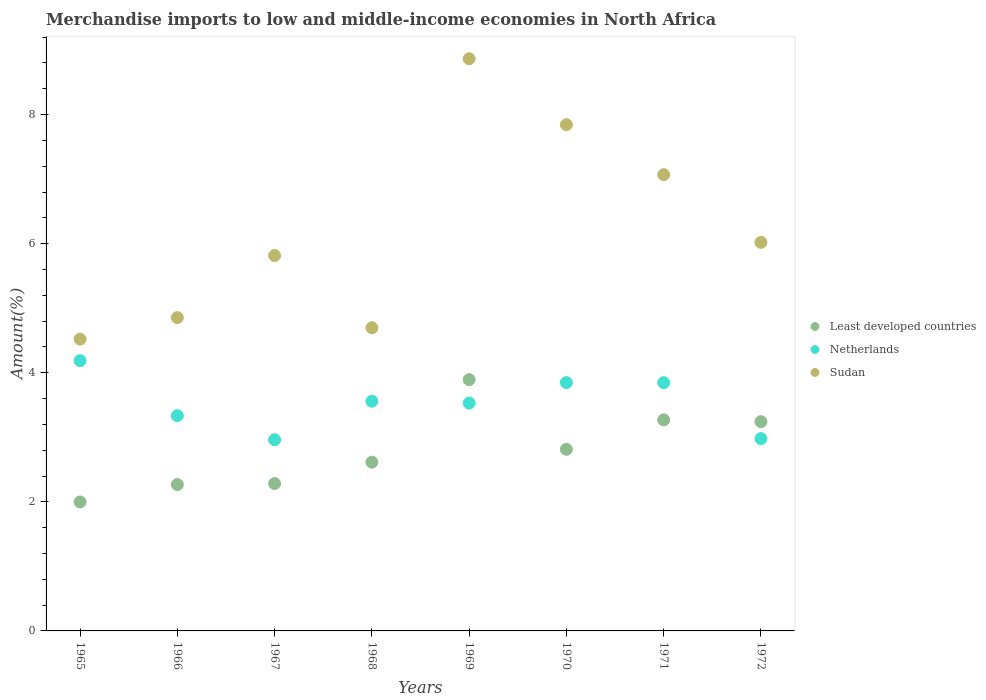How many different coloured dotlines are there?
Keep it short and to the point. 3. What is the percentage of amount earned from merchandise imports in Sudan in 1968?
Your response must be concise. 4.7. Across all years, what is the maximum percentage of amount earned from merchandise imports in Least developed countries?
Ensure brevity in your answer.  3.89. Across all years, what is the minimum percentage of amount earned from merchandise imports in Least developed countries?
Keep it short and to the point. 2. In which year was the percentage of amount earned from merchandise imports in Least developed countries maximum?
Make the answer very short. 1969. In which year was the percentage of amount earned from merchandise imports in Least developed countries minimum?
Make the answer very short. 1965. What is the total percentage of amount earned from merchandise imports in Sudan in the graph?
Make the answer very short. 49.69. What is the difference between the percentage of amount earned from merchandise imports in Netherlands in 1969 and that in 1970?
Your answer should be very brief. -0.32. What is the difference between the percentage of amount earned from merchandise imports in Sudan in 1966 and the percentage of amount earned from merchandise imports in Least developed countries in 1972?
Make the answer very short. 1.61. What is the average percentage of amount earned from merchandise imports in Netherlands per year?
Your answer should be compact. 3.53. In the year 1969, what is the difference between the percentage of amount earned from merchandise imports in Least developed countries and percentage of amount earned from merchandise imports in Netherlands?
Keep it short and to the point. 0.36. What is the ratio of the percentage of amount earned from merchandise imports in Least developed countries in 1967 to that in 1971?
Provide a succinct answer. 0.7. Is the percentage of amount earned from merchandise imports in Netherlands in 1968 less than that in 1971?
Keep it short and to the point. Yes. What is the difference between the highest and the second highest percentage of amount earned from merchandise imports in Least developed countries?
Provide a short and direct response. 0.62. What is the difference between the highest and the lowest percentage of amount earned from merchandise imports in Sudan?
Provide a short and direct response. 4.34. Is the sum of the percentage of amount earned from merchandise imports in Least developed countries in 1966 and 1972 greater than the maximum percentage of amount earned from merchandise imports in Netherlands across all years?
Provide a succinct answer. Yes. Is it the case that in every year, the sum of the percentage of amount earned from merchandise imports in Least developed countries and percentage of amount earned from merchandise imports in Netherlands  is greater than the percentage of amount earned from merchandise imports in Sudan?
Ensure brevity in your answer.  No. Does the percentage of amount earned from merchandise imports in Least developed countries monotonically increase over the years?
Keep it short and to the point. No. Is the percentage of amount earned from merchandise imports in Least developed countries strictly less than the percentage of amount earned from merchandise imports in Netherlands over the years?
Offer a terse response. No. How many dotlines are there?
Keep it short and to the point. 3. Are the values on the major ticks of Y-axis written in scientific E-notation?
Make the answer very short. No. Does the graph contain any zero values?
Offer a terse response. No. Does the graph contain grids?
Ensure brevity in your answer.  No. Where does the legend appear in the graph?
Provide a short and direct response. Center right. How many legend labels are there?
Provide a short and direct response. 3. What is the title of the graph?
Your answer should be compact. Merchandise imports to low and middle-income economies in North Africa. Does "United Kingdom" appear as one of the legend labels in the graph?
Your response must be concise. No. What is the label or title of the X-axis?
Offer a terse response. Years. What is the label or title of the Y-axis?
Provide a succinct answer. Amount(%). What is the Amount(%) in Least developed countries in 1965?
Keep it short and to the point. 2. What is the Amount(%) in Netherlands in 1965?
Keep it short and to the point. 4.19. What is the Amount(%) in Sudan in 1965?
Offer a terse response. 4.52. What is the Amount(%) in Least developed countries in 1966?
Your response must be concise. 2.27. What is the Amount(%) in Netherlands in 1966?
Give a very brief answer. 3.33. What is the Amount(%) in Sudan in 1966?
Your answer should be very brief. 4.85. What is the Amount(%) in Least developed countries in 1967?
Make the answer very short. 2.28. What is the Amount(%) in Netherlands in 1967?
Provide a short and direct response. 2.96. What is the Amount(%) in Sudan in 1967?
Make the answer very short. 5.82. What is the Amount(%) of Least developed countries in 1968?
Provide a short and direct response. 2.61. What is the Amount(%) in Netherlands in 1968?
Offer a terse response. 3.56. What is the Amount(%) in Sudan in 1968?
Keep it short and to the point. 4.7. What is the Amount(%) of Least developed countries in 1969?
Keep it short and to the point. 3.89. What is the Amount(%) of Netherlands in 1969?
Your answer should be compact. 3.53. What is the Amount(%) in Sudan in 1969?
Give a very brief answer. 8.87. What is the Amount(%) of Least developed countries in 1970?
Your response must be concise. 2.81. What is the Amount(%) of Netherlands in 1970?
Give a very brief answer. 3.85. What is the Amount(%) of Sudan in 1970?
Your answer should be very brief. 7.84. What is the Amount(%) of Least developed countries in 1971?
Provide a short and direct response. 3.27. What is the Amount(%) of Netherlands in 1971?
Your answer should be compact. 3.85. What is the Amount(%) of Sudan in 1971?
Provide a short and direct response. 7.07. What is the Amount(%) of Least developed countries in 1972?
Give a very brief answer. 3.24. What is the Amount(%) in Netherlands in 1972?
Offer a very short reply. 2.98. What is the Amount(%) in Sudan in 1972?
Make the answer very short. 6.02. Across all years, what is the maximum Amount(%) of Least developed countries?
Offer a very short reply. 3.89. Across all years, what is the maximum Amount(%) in Netherlands?
Your response must be concise. 4.19. Across all years, what is the maximum Amount(%) of Sudan?
Provide a succinct answer. 8.87. Across all years, what is the minimum Amount(%) in Least developed countries?
Provide a succinct answer. 2. Across all years, what is the minimum Amount(%) of Netherlands?
Ensure brevity in your answer.  2.96. Across all years, what is the minimum Amount(%) in Sudan?
Offer a very short reply. 4.52. What is the total Amount(%) in Least developed countries in the graph?
Your answer should be compact. 22.38. What is the total Amount(%) in Netherlands in the graph?
Offer a very short reply. 28.25. What is the total Amount(%) of Sudan in the graph?
Offer a terse response. 49.69. What is the difference between the Amount(%) in Least developed countries in 1965 and that in 1966?
Offer a very short reply. -0.27. What is the difference between the Amount(%) in Netherlands in 1965 and that in 1966?
Offer a very short reply. 0.85. What is the difference between the Amount(%) in Sudan in 1965 and that in 1966?
Make the answer very short. -0.33. What is the difference between the Amount(%) of Least developed countries in 1965 and that in 1967?
Offer a very short reply. -0.29. What is the difference between the Amount(%) in Netherlands in 1965 and that in 1967?
Keep it short and to the point. 1.23. What is the difference between the Amount(%) of Sudan in 1965 and that in 1967?
Ensure brevity in your answer.  -1.29. What is the difference between the Amount(%) in Least developed countries in 1965 and that in 1968?
Provide a short and direct response. -0.62. What is the difference between the Amount(%) in Netherlands in 1965 and that in 1968?
Ensure brevity in your answer.  0.63. What is the difference between the Amount(%) in Sudan in 1965 and that in 1968?
Offer a terse response. -0.18. What is the difference between the Amount(%) in Least developed countries in 1965 and that in 1969?
Provide a short and direct response. -1.89. What is the difference between the Amount(%) of Netherlands in 1965 and that in 1969?
Your answer should be compact. 0.66. What is the difference between the Amount(%) in Sudan in 1965 and that in 1969?
Your answer should be very brief. -4.34. What is the difference between the Amount(%) in Least developed countries in 1965 and that in 1970?
Provide a short and direct response. -0.82. What is the difference between the Amount(%) of Netherlands in 1965 and that in 1970?
Offer a very short reply. 0.34. What is the difference between the Amount(%) of Sudan in 1965 and that in 1970?
Your answer should be compact. -3.32. What is the difference between the Amount(%) of Least developed countries in 1965 and that in 1971?
Offer a very short reply. -1.27. What is the difference between the Amount(%) of Netherlands in 1965 and that in 1971?
Offer a terse response. 0.34. What is the difference between the Amount(%) in Sudan in 1965 and that in 1971?
Offer a very short reply. -2.55. What is the difference between the Amount(%) of Least developed countries in 1965 and that in 1972?
Your answer should be compact. -1.24. What is the difference between the Amount(%) in Netherlands in 1965 and that in 1972?
Provide a short and direct response. 1.21. What is the difference between the Amount(%) of Sudan in 1965 and that in 1972?
Provide a short and direct response. -1.5. What is the difference between the Amount(%) in Least developed countries in 1966 and that in 1967?
Your answer should be compact. -0.02. What is the difference between the Amount(%) in Netherlands in 1966 and that in 1967?
Give a very brief answer. 0.37. What is the difference between the Amount(%) of Sudan in 1966 and that in 1967?
Offer a very short reply. -0.96. What is the difference between the Amount(%) in Least developed countries in 1966 and that in 1968?
Give a very brief answer. -0.35. What is the difference between the Amount(%) of Netherlands in 1966 and that in 1968?
Give a very brief answer. -0.22. What is the difference between the Amount(%) of Sudan in 1966 and that in 1968?
Your response must be concise. 0.16. What is the difference between the Amount(%) in Least developed countries in 1966 and that in 1969?
Ensure brevity in your answer.  -1.62. What is the difference between the Amount(%) in Netherlands in 1966 and that in 1969?
Offer a terse response. -0.2. What is the difference between the Amount(%) in Sudan in 1966 and that in 1969?
Provide a short and direct response. -4.01. What is the difference between the Amount(%) of Least developed countries in 1966 and that in 1970?
Make the answer very short. -0.55. What is the difference between the Amount(%) of Netherlands in 1966 and that in 1970?
Your response must be concise. -0.51. What is the difference between the Amount(%) in Sudan in 1966 and that in 1970?
Make the answer very short. -2.99. What is the difference between the Amount(%) in Least developed countries in 1966 and that in 1971?
Give a very brief answer. -1. What is the difference between the Amount(%) of Netherlands in 1966 and that in 1971?
Provide a short and direct response. -0.51. What is the difference between the Amount(%) in Sudan in 1966 and that in 1971?
Ensure brevity in your answer.  -2.22. What is the difference between the Amount(%) of Least developed countries in 1966 and that in 1972?
Provide a succinct answer. -0.97. What is the difference between the Amount(%) of Netherlands in 1966 and that in 1972?
Provide a succinct answer. 0.36. What is the difference between the Amount(%) in Sudan in 1966 and that in 1972?
Provide a succinct answer. -1.17. What is the difference between the Amount(%) in Least developed countries in 1967 and that in 1968?
Ensure brevity in your answer.  -0.33. What is the difference between the Amount(%) of Netherlands in 1967 and that in 1968?
Your answer should be very brief. -0.6. What is the difference between the Amount(%) of Sudan in 1967 and that in 1968?
Give a very brief answer. 1.12. What is the difference between the Amount(%) of Least developed countries in 1967 and that in 1969?
Your response must be concise. -1.61. What is the difference between the Amount(%) of Netherlands in 1967 and that in 1969?
Offer a terse response. -0.57. What is the difference between the Amount(%) in Sudan in 1967 and that in 1969?
Make the answer very short. -3.05. What is the difference between the Amount(%) in Least developed countries in 1967 and that in 1970?
Offer a very short reply. -0.53. What is the difference between the Amount(%) of Netherlands in 1967 and that in 1970?
Your answer should be compact. -0.89. What is the difference between the Amount(%) in Sudan in 1967 and that in 1970?
Make the answer very short. -2.03. What is the difference between the Amount(%) in Least developed countries in 1967 and that in 1971?
Give a very brief answer. -0.99. What is the difference between the Amount(%) in Netherlands in 1967 and that in 1971?
Your answer should be very brief. -0.88. What is the difference between the Amount(%) of Sudan in 1967 and that in 1971?
Your response must be concise. -1.25. What is the difference between the Amount(%) of Least developed countries in 1967 and that in 1972?
Provide a succinct answer. -0.96. What is the difference between the Amount(%) of Netherlands in 1967 and that in 1972?
Keep it short and to the point. -0.02. What is the difference between the Amount(%) of Sudan in 1967 and that in 1972?
Give a very brief answer. -0.2. What is the difference between the Amount(%) of Least developed countries in 1968 and that in 1969?
Offer a terse response. -1.28. What is the difference between the Amount(%) of Netherlands in 1968 and that in 1969?
Your answer should be compact. 0.03. What is the difference between the Amount(%) in Sudan in 1968 and that in 1969?
Give a very brief answer. -4.17. What is the difference between the Amount(%) in Least developed countries in 1968 and that in 1970?
Provide a succinct answer. -0.2. What is the difference between the Amount(%) of Netherlands in 1968 and that in 1970?
Your answer should be compact. -0.29. What is the difference between the Amount(%) in Sudan in 1968 and that in 1970?
Offer a very short reply. -3.15. What is the difference between the Amount(%) of Least developed countries in 1968 and that in 1971?
Provide a short and direct response. -0.65. What is the difference between the Amount(%) of Netherlands in 1968 and that in 1971?
Your answer should be very brief. -0.29. What is the difference between the Amount(%) in Sudan in 1968 and that in 1971?
Your answer should be very brief. -2.37. What is the difference between the Amount(%) of Least developed countries in 1968 and that in 1972?
Your answer should be very brief. -0.63. What is the difference between the Amount(%) in Netherlands in 1968 and that in 1972?
Keep it short and to the point. 0.58. What is the difference between the Amount(%) in Sudan in 1968 and that in 1972?
Your answer should be compact. -1.32. What is the difference between the Amount(%) in Least developed countries in 1969 and that in 1970?
Your response must be concise. 1.08. What is the difference between the Amount(%) in Netherlands in 1969 and that in 1970?
Your answer should be very brief. -0.32. What is the difference between the Amount(%) in Sudan in 1969 and that in 1970?
Provide a short and direct response. 1.02. What is the difference between the Amount(%) of Least developed countries in 1969 and that in 1971?
Provide a succinct answer. 0.62. What is the difference between the Amount(%) of Netherlands in 1969 and that in 1971?
Give a very brief answer. -0.32. What is the difference between the Amount(%) in Sudan in 1969 and that in 1971?
Your answer should be very brief. 1.8. What is the difference between the Amount(%) of Least developed countries in 1969 and that in 1972?
Keep it short and to the point. 0.65. What is the difference between the Amount(%) of Netherlands in 1969 and that in 1972?
Give a very brief answer. 0.55. What is the difference between the Amount(%) in Sudan in 1969 and that in 1972?
Make the answer very short. 2.84. What is the difference between the Amount(%) of Least developed countries in 1970 and that in 1971?
Make the answer very short. -0.46. What is the difference between the Amount(%) of Netherlands in 1970 and that in 1971?
Your answer should be very brief. 0. What is the difference between the Amount(%) in Sudan in 1970 and that in 1971?
Give a very brief answer. 0.77. What is the difference between the Amount(%) of Least developed countries in 1970 and that in 1972?
Provide a short and direct response. -0.43. What is the difference between the Amount(%) of Netherlands in 1970 and that in 1972?
Offer a very short reply. 0.87. What is the difference between the Amount(%) of Sudan in 1970 and that in 1972?
Ensure brevity in your answer.  1.82. What is the difference between the Amount(%) of Least developed countries in 1971 and that in 1972?
Offer a very short reply. 0.03. What is the difference between the Amount(%) in Netherlands in 1971 and that in 1972?
Offer a very short reply. 0.87. What is the difference between the Amount(%) of Sudan in 1971 and that in 1972?
Your answer should be compact. 1.05. What is the difference between the Amount(%) of Least developed countries in 1965 and the Amount(%) of Netherlands in 1966?
Keep it short and to the point. -1.34. What is the difference between the Amount(%) in Least developed countries in 1965 and the Amount(%) in Sudan in 1966?
Make the answer very short. -2.86. What is the difference between the Amount(%) in Netherlands in 1965 and the Amount(%) in Sudan in 1966?
Your answer should be compact. -0.67. What is the difference between the Amount(%) in Least developed countries in 1965 and the Amount(%) in Netherlands in 1967?
Offer a terse response. -0.96. What is the difference between the Amount(%) of Least developed countries in 1965 and the Amount(%) of Sudan in 1967?
Your answer should be very brief. -3.82. What is the difference between the Amount(%) in Netherlands in 1965 and the Amount(%) in Sudan in 1967?
Your answer should be compact. -1.63. What is the difference between the Amount(%) in Least developed countries in 1965 and the Amount(%) in Netherlands in 1968?
Offer a terse response. -1.56. What is the difference between the Amount(%) of Least developed countries in 1965 and the Amount(%) of Sudan in 1968?
Offer a terse response. -2.7. What is the difference between the Amount(%) of Netherlands in 1965 and the Amount(%) of Sudan in 1968?
Provide a short and direct response. -0.51. What is the difference between the Amount(%) of Least developed countries in 1965 and the Amount(%) of Netherlands in 1969?
Offer a very short reply. -1.53. What is the difference between the Amount(%) in Least developed countries in 1965 and the Amount(%) in Sudan in 1969?
Your answer should be very brief. -6.87. What is the difference between the Amount(%) in Netherlands in 1965 and the Amount(%) in Sudan in 1969?
Keep it short and to the point. -4.68. What is the difference between the Amount(%) of Least developed countries in 1965 and the Amount(%) of Netherlands in 1970?
Your answer should be compact. -1.85. What is the difference between the Amount(%) in Least developed countries in 1965 and the Amount(%) in Sudan in 1970?
Make the answer very short. -5.85. What is the difference between the Amount(%) in Netherlands in 1965 and the Amount(%) in Sudan in 1970?
Your answer should be very brief. -3.66. What is the difference between the Amount(%) in Least developed countries in 1965 and the Amount(%) in Netherlands in 1971?
Your response must be concise. -1.85. What is the difference between the Amount(%) in Least developed countries in 1965 and the Amount(%) in Sudan in 1971?
Ensure brevity in your answer.  -5.07. What is the difference between the Amount(%) in Netherlands in 1965 and the Amount(%) in Sudan in 1971?
Keep it short and to the point. -2.88. What is the difference between the Amount(%) in Least developed countries in 1965 and the Amount(%) in Netherlands in 1972?
Keep it short and to the point. -0.98. What is the difference between the Amount(%) of Least developed countries in 1965 and the Amount(%) of Sudan in 1972?
Offer a terse response. -4.02. What is the difference between the Amount(%) in Netherlands in 1965 and the Amount(%) in Sudan in 1972?
Give a very brief answer. -1.83. What is the difference between the Amount(%) of Least developed countries in 1966 and the Amount(%) of Netherlands in 1967?
Your response must be concise. -0.69. What is the difference between the Amount(%) of Least developed countries in 1966 and the Amount(%) of Sudan in 1967?
Your answer should be very brief. -3.55. What is the difference between the Amount(%) in Netherlands in 1966 and the Amount(%) in Sudan in 1967?
Your answer should be very brief. -2.48. What is the difference between the Amount(%) of Least developed countries in 1966 and the Amount(%) of Netherlands in 1968?
Ensure brevity in your answer.  -1.29. What is the difference between the Amount(%) of Least developed countries in 1966 and the Amount(%) of Sudan in 1968?
Offer a very short reply. -2.43. What is the difference between the Amount(%) in Netherlands in 1966 and the Amount(%) in Sudan in 1968?
Provide a succinct answer. -1.36. What is the difference between the Amount(%) of Least developed countries in 1966 and the Amount(%) of Netherlands in 1969?
Keep it short and to the point. -1.26. What is the difference between the Amount(%) in Least developed countries in 1966 and the Amount(%) in Sudan in 1969?
Give a very brief answer. -6.6. What is the difference between the Amount(%) of Netherlands in 1966 and the Amount(%) of Sudan in 1969?
Provide a short and direct response. -5.53. What is the difference between the Amount(%) in Least developed countries in 1966 and the Amount(%) in Netherlands in 1970?
Provide a short and direct response. -1.58. What is the difference between the Amount(%) in Least developed countries in 1966 and the Amount(%) in Sudan in 1970?
Ensure brevity in your answer.  -5.58. What is the difference between the Amount(%) in Netherlands in 1966 and the Amount(%) in Sudan in 1970?
Your answer should be very brief. -4.51. What is the difference between the Amount(%) of Least developed countries in 1966 and the Amount(%) of Netherlands in 1971?
Keep it short and to the point. -1.58. What is the difference between the Amount(%) in Least developed countries in 1966 and the Amount(%) in Sudan in 1971?
Ensure brevity in your answer.  -4.8. What is the difference between the Amount(%) in Netherlands in 1966 and the Amount(%) in Sudan in 1971?
Provide a succinct answer. -3.73. What is the difference between the Amount(%) in Least developed countries in 1966 and the Amount(%) in Netherlands in 1972?
Make the answer very short. -0.71. What is the difference between the Amount(%) in Least developed countries in 1966 and the Amount(%) in Sudan in 1972?
Give a very brief answer. -3.75. What is the difference between the Amount(%) in Netherlands in 1966 and the Amount(%) in Sudan in 1972?
Your response must be concise. -2.69. What is the difference between the Amount(%) in Least developed countries in 1967 and the Amount(%) in Netherlands in 1968?
Make the answer very short. -1.28. What is the difference between the Amount(%) of Least developed countries in 1967 and the Amount(%) of Sudan in 1968?
Give a very brief answer. -2.41. What is the difference between the Amount(%) in Netherlands in 1967 and the Amount(%) in Sudan in 1968?
Offer a terse response. -1.74. What is the difference between the Amount(%) of Least developed countries in 1967 and the Amount(%) of Netherlands in 1969?
Your answer should be compact. -1.25. What is the difference between the Amount(%) in Least developed countries in 1967 and the Amount(%) in Sudan in 1969?
Provide a short and direct response. -6.58. What is the difference between the Amount(%) of Netherlands in 1967 and the Amount(%) of Sudan in 1969?
Offer a terse response. -5.9. What is the difference between the Amount(%) of Least developed countries in 1967 and the Amount(%) of Netherlands in 1970?
Provide a succinct answer. -1.56. What is the difference between the Amount(%) in Least developed countries in 1967 and the Amount(%) in Sudan in 1970?
Offer a terse response. -5.56. What is the difference between the Amount(%) of Netherlands in 1967 and the Amount(%) of Sudan in 1970?
Your answer should be compact. -4.88. What is the difference between the Amount(%) of Least developed countries in 1967 and the Amount(%) of Netherlands in 1971?
Your answer should be compact. -1.56. What is the difference between the Amount(%) in Least developed countries in 1967 and the Amount(%) in Sudan in 1971?
Ensure brevity in your answer.  -4.79. What is the difference between the Amount(%) of Netherlands in 1967 and the Amount(%) of Sudan in 1971?
Offer a very short reply. -4.11. What is the difference between the Amount(%) in Least developed countries in 1967 and the Amount(%) in Netherlands in 1972?
Ensure brevity in your answer.  -0.7. What is the difference between the Amount(%) in Least developed countries in 1967 and the Amount(%) in Sudan in 1972?
Make the answer very short. -3.74. What is the difference between the Amount(%) of Netherlands in 1967 and the Amount(%) of Sudan in 1972?
Ensure brevity in your answer.  -3.06. What is the difference between the Amount(%) of Least developed countries in 1968 and the Amount(%) of Netherlands in 1969?
Your response must be concise. -0.92. What is the difference between the Amount(%) of Least developed countries in 1968 and the Amount(%) of Sudan in 1969?
Your answer should be compact. -6.25. What is the difference between the Amount(%) of Netherlands in 1968 and the Amount(%) of Sudan in 1969?
Provide a succinct answer. -5.31. What is the difference between the Amount(%) in Least developed countries in 1968 and the Amount(%) in Netherlands in 1970?
Your answer should be compact. -1.23. What is the difference between the Amount(%) of Least developed countries in 1968 and the Amount(%) of Sudan in 1970?
Provide a short and direct response. -5.23. What is the difference between the Amount(%) of Netherlands in 1968 and the Amount(%) of Sudan in 1970?
Make the answer very short. -4.28. What is the difference between the Amount(%) of Least developed countries in 1968 and the Amount(%) of Netherlands in 1971?
Ensure brevity in your answer.  -1.23. What is the difference between the Amount(%) in Least developed countries in 1968 and the Amount(%) in Sudan in 1971?
Your response must be concise. -4.45. What is the difference between the Amount(%) of Netherlands in 1968 and the Amount(%) of Sudan in 1971?
Ensure brevity in your answer.  -3.51. What is the difference between the Amount(%) of Least developed countries in 1968 and the Amount(%) of Netherlands in 1972?
Your answer should be compact. -0.36. What is the difference between the Amount(%) of Least developed countries in 1968 and the Amount(%) of Sudan in 1972?
Your answer should be very brief. -3.41. What is the difference between the Amount(%) of Netherlands in 1968 and the Amount(%) of Sudan in 1972?
Provide a short and direct response. -2.46. What is the difference between the Amount(%) of Least developed countries in 1969 and the Amount(%) of Netherlands in 1970?
Keep it short and to the point. 0.04. What is the difference between the Amount(%) in Least developed countries in 1969 and the Amount(%) in Sudan in 1970?
Ensure brevity in your answer.  -3.95. What is the difference between the Amount(%) in Netherlands in 1969 and the Amount(%) in Sudan in 1970?
Ensure brevity in your answer.  -4.31. What is the difference between the Amount(%) of Least developed countries in 1969 and the Amount(%) of Netherlands in 1971?
Provide a succinct answer. 0.05. What is the difference between the Amount(%) in Least developed countries in 1969 and the Amount(%) in Sudan in 1971?
Offer a very short reply. -3.18. What is the difference between the Amount(%) of Netherlands in 1969 and the Amount(%) of Sudan in 1971?
Your response must be concise. -3.54. What is the difference between the Amount(%) of Least developed countries in 1969 and the Amount(%) of Netherlands in 1972?
Your answer should be compact. 0.91. What is the difference between the Amount(%) of Least developed countries in 1969 and the Amount(%) of Sudan in 1972?
Make the answer very short. -2.13. What is the difference between the Amount(%) of Netherlands in 1969 and the Amount(%) of Sudan in 1972?
Ensure brevity in your answer.  -2.49. What is the difference between the Amount(%) of Least developed countries in 1970 and the Amount(%) of Netherlands in 1971?
Offer a terse response. -1.03. What is the difference between the Amount(%) in Least developed countries in 1970 and the Amount(%) in Sudan in 1971?
Make the answer very short. -4.26. What is the difference between the Amount(%) of Netherlands in 1970 and the Amount(%) of Sudan in 1971?
Your response must be concise. -3.22. What is the difference between the Amount(%) of Least developed countries in 1970 and the Amount(%) of Netherlands in 1972?
Your response must be concise. -0.17. What is the difference between the Amount(%) of Least developed countries in 1970 and the Amount(%) of Sudan in 1972?
Make the answer very short. -3.21. What is the difference between the Amount(%) in Netherlands in 1970 and the Amount(%) in Sudan in 1972?
Make the answer very short. -2.17. What is the difference between the Amount(%) in Least developed countries in 1971 and the Amount(%) in Netherlands in 1972?
Your answer should be very brief. 0.29. What is the difference between the Amount(%) of Least developed countries in 1971 and the Amount(%) of Sudan in 1972?
Ensure brevity in your answer.  -2.75. What is the difference between the Amount(%) of Netherlands in 1971 and the Amount(%) of Sudan in 1972?
Offer a very short reply. -2.17. What is the average Amount(%) of Least developed countries per year?
Provide a succinct answer. 2.8. What is the average Amount(%) of Netherlands per year?
Provide a short and direct response. 3.53. What is the average Amount(%) of Sudan per year?
Provide a short and direct response. 6.21. In the year 1965, what is the difference between the Amount(%) of Least developed countries and Amount(%) of Netherlands?
Offer a very short reply. -2.19. In the year 1965, what is the difference between the Amount(%) in Least developed countries and Amount(%) in Sudan?
Keep it short and to the point. -2.52. In the year 1965, what is the difference between the Amount(%) of Netherlands and Amount(%) of Sudan?
Your answer should be very brief. -0.33. In the year 1966, what is the difference between the Amount(%) in Least developed countries and Amount(%) in Netherlands?
Your response must be concise. -1.07. In the year 1966, what is the difference between the Amount(%) of Least developed countries and Amount(%) of Sudan?
Keep it short and to the point. -2.59. In the year 1966, what is the difference between the Amount(%) of Netherlands and Amount(%) of Sudan?
Your answer should be compact. -1.52. In the year 1967, what is the difference between the Amount(%) in Least developed countries and Amount(%) in Netherlands?
Offer a terse response. -0.68. In the year 1967, what is the difference between the Amount(%) in Least developed countries and Amount(%) in Sudan?
Make the answer very short. -3.53. In the year 1967, what is the difference between the Amount(%) of Netherlands and Amount(%) of Sudan?
Offer a terse response. -2.85. In the year 1968, what is the difference between the Amount(%) in Least developed countries and Amount(%) in Netherlands?
Keep it short and to the point. -0.94. In the year 1968, what is the difference between the Amount(%) in Least developed countries and Amount(%) in Sudan?
Provide a short and direct response. -2.08. In the year 1968, what is the difference between the Amount(%) in Netherlands and Amount(%) in Sudan?
Provide a short and direct response. -1.14. In the year 1969, what is the difference between the Amount(%) of Least developed countries and Amount(%) of Netherlands?
Your answer should be very brief. 0.36. In the year 1969, what is the difference between the Amount(%) in Least developed countries and Amount(%) in Sudan?
Keep it short and to the point. -4.97. In the year 1969, what is the difference between the Amount(%) in Netherlands and Amount(%) in Sudan?
Your answer should be very brief. -5.33. In the year 1970, what is the difference between the Amount(%) of Least developed countries and Amount(%) of Netherlands?
Provide a short and direct response. -1.03. In the year 1970, what is the difference between the Amount(%) of Least developed countries and Amount(%) of Sudan?
Provide a short and direct response. -5.03. In the year 1970, what is the difference between the Amount(%) in Netherlands and Amount(%) in Sudan?
Keep it short and to the point. -4. In the year 1971, what is the difference between the Amount(%) of Least developed countries and Amount(%) of Netherlands?
Give a very brief answer. -0.58. In the year 1971, what is the difference between the Amount(%) in Least developed countries and Amount(%) in Sudan?
Ensure brevity in your answer.  -3.8. In the year 1971, what is the difference between the Amount(%) of Netherlands and Amount(%) of Sudan?
Your answer should be compact. -3.22. In the year 1972, what is the difference between the Amount(%) of Least developed countries and Amount(%) of Netherlands?
Give a very brief answer. 0.26. In the year 1972, what is the difference between the Amount(%) in Least developed countries and Amount(%) in Sudan?
Provide a short and direct response. -2.78. In the year 1972, what is the difference between the Amount(%) in Netherlands and Amount(%) in Sudan?
Offer a very short reply. -3.04. What is the ratio of the Amount(%) of Least developed countries in 1965 to that in 1966?
Your answer should be very brief. 0.88. What is the ratio of the Amount(%) in Netherlands in 1965 to that in 1966?
Keep it short and to the point. 1.26. What is the ratio of the Amount(%) in Sudan in 1965 to that in 1966?
Give a very brief answer. 0.93. What is the ratio of the Amount(%) in Netherlands in 1965 to that in 1967?
Provide a succinct answer. 1.41. What is the ratio of the Amount(%) of Sudan in 1965 to that in 1967?
Provide a succinct answer. 0.78. What is the ratio of the Amount(%) of Least developed countries in 1965 to that in 1968?
Provide a short and direct response. 0.76. What is the ratio of the Amount(%) in Netherlands in 1965 to that in 1968?
Make the answer very short. 1.18. What is the ratio of the Amount(%) in Sudan in 1965 to that in 1968?
Ensure brevity in your answer.  0.96. What is the ratio of the Amount(%) in Least developed countries in 1965 to that in 1969?
Ensure brevity in your answer.  0.51. What is the ratio of the Amount(%) in Netherlands in 1965 to that in 1969?
Ensure brevity in your answer.  1.19. What is the ratio of the Amount(%) in Sudan in 1965 to that in 1969?
Your answer should be very brief. 0.51. What is the ratio of the Amount(%) of Least developed countries in 1965 to that in 1970?
Offer a terse response. 0.71. What is the ratio of the Amount(%) of Netherlands in 1965 to that in 1970?
Give a very brief answer. 1.09. What is the ratio of the Amount(%) of Sudan in 1965 to that in 1970?
Make the answer very short. 0.58. What is the ratio of the Amount(%) of Least developed countries in 1965 to that in 1971?
Ensure brevity in your answer.  0.61. What is the ratio of the Amount(%) of Netherlands in 1965 to that in 1971?
Keep it short and to the point. 1.09. What is the ratio of the Amount(%) in Sudan in 1965 to that in 1971?
Your answer should be compact. 0.64. What is the ratio of the Amount(%) of Least developed countries in 1965 to that in 1972?
Give a very brief answer. 0.62. What is the ratio of the Amount(%) in Netherlands in 1965 to that in 1972?
Make the answer very short. 1.41. What is the ratio of the Amount(%) of Sudan in 1965 to that in 1972?
Your answer should be very brief. 0.75. What is the ratio of the Amount(%) of Netherlands in 1966 to that in 1967?
Offer a very short reply. 1.13. What is the ratio of the Amount(%) of Sudan in 1966 to that in 1967?
Keep it short and to the point. 0.83. What is the ratio of the Amount(%) of Least developed countries in 1966 to that in 1968?
Provide a succinct answer. 0.87. What is the ratio of the Amount(%) of Netherlands in 1966 to that in 1968?
Provide a succinct answer. 0.94. What is the ratio of the Amount(%) of Sudan in 1966 to that in 1968?
Offer a very short reply. 1.03. What is the ratio of the Amount(%) in Least developed countries in 1966 to that in 1969?
Offer a very short reply. 0.58. What is the ratio of the Amount(%) in Netherlands in 1966 to that in 1969?
Give a very brief answer. 0.94. What is the ratio of the Amount(%) in Sudan in 1966 to that in 1969?
Your answer should be very brief. 0.55. What is the ratio of the Amount(%) in Least developed countries in 1966 to that in 1970?
Your response must be concise. 0.81. What is the ratio of the Amount(%) in Netherlands in 1966 to that in 1970?
Ensure brevity in your answer.  0.87. What is the ratio of the Amount(%) of Sudan in 1966 to that in 1970?
Your answer should be compact. 0.62. What is the ratio of the Amount(%) of Least developed countries in 1966 to that in 1971?
Your answer should be compact. 0.69. What is the ratio of the Amount(%) in Netherlands in 1966 to that in 1971?
Ensure brevity in your answer.  0.87. What is the ratio of the Amount(%) of Sudan in 1966 to that in 1971?
Keep it short and to the point. 0.69. What is the ratio of the Amount(%) of Least developed countries in 1966 to that in 1972?
Ensure brevity in your answer.  0.7. What is the ratio of the Amount(%) of Netherlands in 1966 to that in 1972?
Offer a very short reply. 1.12. What is the ratio of the Amount(%) of Sudan in 1966 to that in 1972?
Your answer should be very brief. 0.81. What is the ratio of the Amount(%) in Least developed countries in 1967 to that in 1968?
Provide a short and direct response. 0.87. What is the ratio of the Amount(%) in Netherlands in 1967 to that in 1968?
Ensure brevity in your answer.  0.83. What is the ratio of the Amount(%) of Sudan in 1967 to that in 1968?
Provide a short and direct response. 1.24. What is the ratio of the Amount(%) in Least developed countries in 1967 to that in 1969?
Keep it short and to the point. 0.59. What is the ratio of the Amount(%) in Netherlands in 1967 to that in 1969?
Your answer should be very brief. 0.84. What is the ratio of the Amount(%) of Sudan in 1967 to that in 1969?
Your answer should be very brief. 0.66. What is the ratio of the Amount(%) in Least developed countries in 1967 to that in 1970?
Ensure brevity in your answer.  0.81. What is the ratio of the Amount(%) of Netherlands in 1967 to that in 1970?
Make the answer very short. 0.77. What is the ratio of the Amount(%) in Sudan in 1967 to that in 1970?
Make the answer very short. 0.74. What is the ratio of the Amount(%) of Least developed countries in 1967 to that in 1971?
Your answer should be very brief. 0.7. What is the ratio of the Amount(%) of Netherlands in 1967 to that in 1971?
Provide a succinct answer. 0.77. What is the ratio of the Amount(%) of Sudan in 1967 to that in 1971?
Ensure brevity in your answer.  0.82. What is the ratio of the Amount(%) of Least developed countries in 1967 to that in 1972?
Keep it short and to the point. 0.7. What is the ratio of the Amount(%) of Netherlands in 1967 to that in 1972?
Give a very brief answer. 0.99. What is the ratio of the Amount(%) of Sudan in 1967 to that in 1972?
Provide a succinct answer. 0.97. What is the ratio of the Amount(%) of Least developed countries in 1968 to that in 1969?
Offer a very short reply. 0.67. What is the ratio of the Amount(%) in Netherlands in 1968 to that in 1969?
Give a very brief answer. 1.01. What is the ratio of the Amount(%) of Sudan in 1968 to that in 1969?
Make the answer very short. 0.53. What is the ratio of the Amount(%) in Least developed countries in 1968 to that in 1970?
Make the answer very short. 0.93. What is the ratio of the Amount(%) in Netherlands in 1968 to that in 1970?
Offer a very short reply. 0.92. What is the ratio of the Amount(%) of Sudan in 1968 to that in 1970?
Offer a terse response. 0.6. What is the ratio of the Amount(%) in Least developed countries in 1968 to that in 1971?
Offer a terse response. 0.8. What is the ratio of the Amount(%) in Netherlands in 1968 to that in 1971?
Your answer should be compact. 0.93. What is the ratio of the Amount(%) of Sudan in 1968 to that in 1971?
Keep it short and to the point. 0.66. What is the ratio of the Amount(%) of Least developed countries in 1968 to that in 1972?
Offer a very short reply. 0.81. What is the ratio of the Amount(%) of Netherlands in 1968 to that in 1972?
Your answer should be very brief. 1.19. What is the ratio of the Amount(%) in Sudan in 1968 to that in 1972?
Your answer should be compact. 0.78. What is the ratio of the Amount(%) in Least developed countries in 1969 to that in 1970?
Your answer should be compact. 1.38. What is the ratio of the Amount(%) in Netherlands in 1969 to that in 1970?
Give a very brief answer. 0.92. What is the ratio of the Amount(%) in Sudan in 1969 to that in 1970?
Give a very brief answer. 1.13. What is the ratio of the Amount(%) in Least developed countries in 1969 to that in 1971?
Provide a short and direct response. 1.19. What is the ratio of the Amount(%) of Netherlands in 1969 to that in 1971?
Offer a terse response. 0.92. What is the ratio of the Amount(%) in Sudan in 1969 to that in 1971?
Provide a short and direct response. 1.25. What is the ratio of the Amount(%) in Least developed countries in 1969 to that in 1972?
Your answer should be very brief. 1.2. What is the ratio of the Amount(%) of Netherlands in 1969 to that in 1972?
Provide a succinct answer. 1.18. What is the ratio of the Amount(%) in Sudan in 1969 to that in 1972?
Offer a terse response. 1.47. What is the ratio of the Amount(%) of Least developed countries in 1970 to that in 1971?
Provide a succinct answer. 0.86. What is the ratio of the Amount(%) in Netherlands in 1970 to that in 1971?
Provide a succinct answer. 1. What is the ratio of the Amount(%) of Sudan in 1970 to that in 1971?
Your answer should be very brief. 1.11. What is the ratio of the Amount(%) of Least developed countries in 1970 to that in 1972?
Offer a very short reply. 0.87. What is the ratio of the Amount(%) in Netherlands in 1970 to that in 1972?
Offer a very short reply. 1.29. What is the ratio of the Amount(%) of Sudan in 1970 to that in 1972?
Provide a succinct answer. 1.3. What is the ratio of the Amount(%) in Least developed countries in 1971 to that in 1972?
Your answer should be very brief. 1.01. What is the ratio of the Amount(%) of Netherlands in 1971 to that in 1972?
Your answer should be very brief. 1.29. What is the ratio of the Amount(%) in Sudan in 1971 to that in 1972?
Give a very brief answer. 1.17. What is the difference between the highest and the second highest Amount(%) in Least developed countries?
Your response must be concise. 0.62. What is the difference between the highest and the second highest Amount(%) in Netherlands?
Offer a very short reply. 0.34. What is the difference between the highest and the second highest Amount(%) of Sudan?
Make the answer very short. 1.02. What is the difference between the highest and the lowest Amount(%) in Least developed countries?
Offer a terse response. 1.89. What is the difference between the highest and the lowest Amount(%) in Netherlands?
Your answer should be very brief. 1.23. What is the difference between the highest and the lowest Amount(%) in Sudan?
Provide a succinct answer. 4.34. 